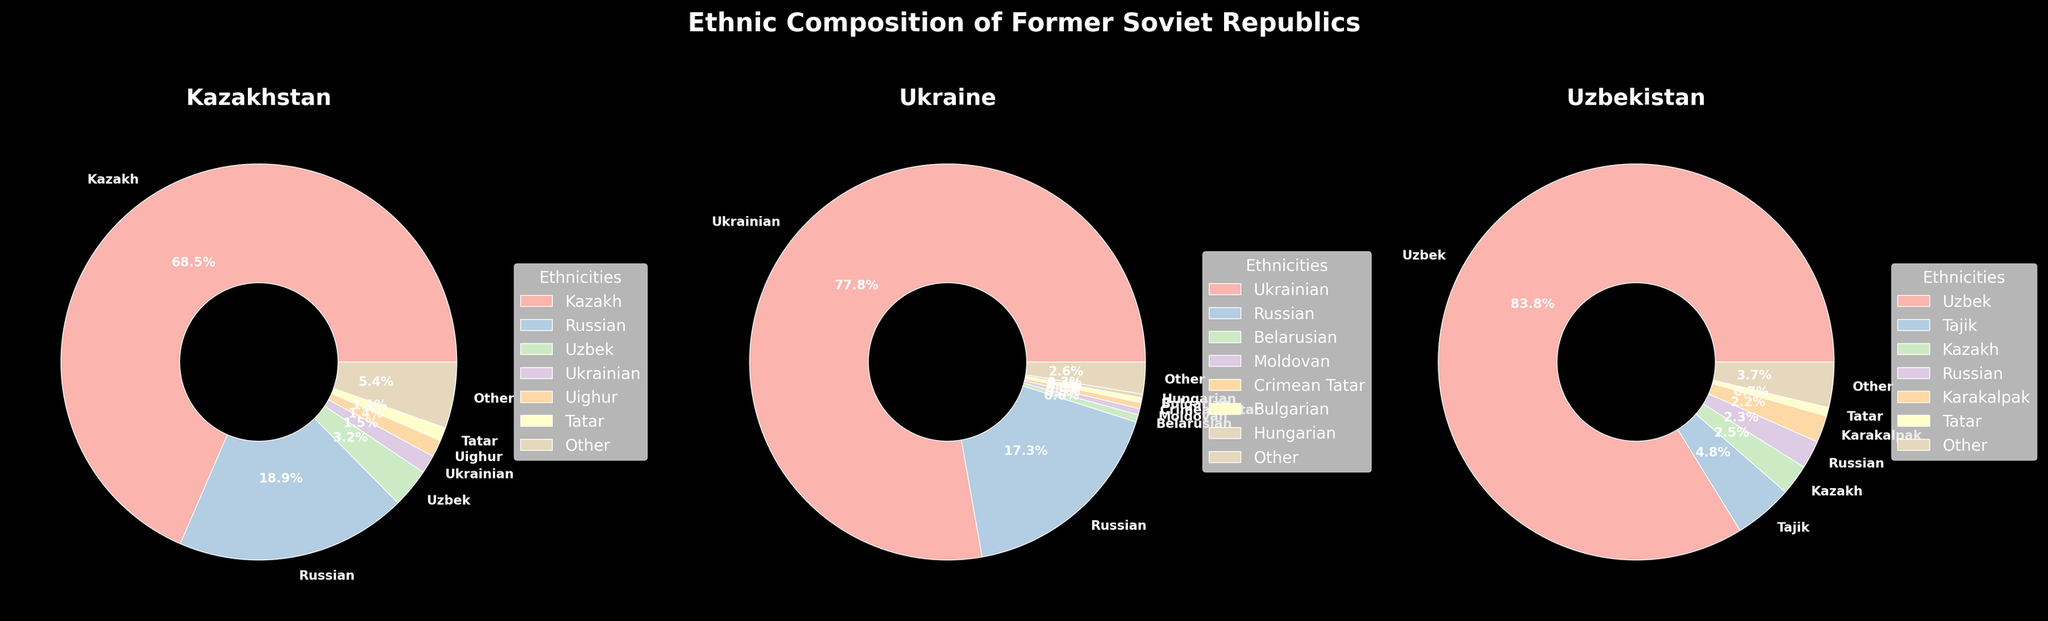what percentage of the population in Kazakhstan is non-Kazakh? To find the percentage of the population in Kazakhstan that is non-Kazakh, add up the percentages of all the other ethnic groups: Russian (18.9%), Uzbek (3.2%), Ukrainian (1.5%), Uighur (1.4%), Tatar (1.1%), and Other (5.4%). Sum these percentages: 18.9 + 3.2 + 1.5 + 1.4 + 1.1 + 5.4 = 31.5%.
Answer: 31.5% Which country has the highest percentage of its population from a single ethnic group? By visually comparing the largest slice of each pie chart, Uzbekistan has the highest percentage of its population from a single ethnic group, with the Uzbek ethnicity making up 83.8%.
Answer: Uzbekistan What is the combined percentage of Russian populations in Kazakhstan and Ukraine? Add the Russian population percentage in Kazakhstan (18.9%) to the Russian population percentage in Ukraine (17.3%). The combined percentage is 18.9 + 17.3 = 36.2%.
Answer: 36.2% Is there a significant difference in the proportion of the main ethnic group between Kazakhstan and Uzbekistan? Compare the percentages of the main ethnic group in both countries. In Kazakhstan, Kazakhs make up 68.5% of the population, while in Uzbekistan, Uzbeks make up 83.8% of the population. The difference is 83.8 - 68.5 = 15.3%. This shows a significant difference.
Answer: Yes, 15.3% What is the percentage difference between Ukrainians and Russians in Ukraine? Subtract the percentage of Russians (17.3%) from the percentage of Ukrainians (77.8%) to find the difference: 77.8 - 17.3 = 60.5%.
Answer: 60.5% How does the ethnic diversity in Kazakhstan compare to that in Uzbekistan? Kazakhstan has several ethnic groups with significant percentages: Kazakh (68.5%), Russian (18.9%), Uzbek (3.2%), and others. Uzbekistan has fewer groups with high percentages: Uzbek (83.8%) and Tajik (4.8%). This indicates higher ethnic diversity in Kazakhstan.
Answer: Kazakhstan is more diverse What is the second-largest ethnic group in Uzbekistan and what percentage of the population does it represent? The second-largest ethnic group in Uzbekistan is Tajik, which represents 4.8% of the population.
Answer: Tajik, 4.8% What color represents the Kazakh ethnic group in Kazakhstan? From the visual observation of the pie chart, the Kazakh ethnic group is represented by the largest slice in the Kazakhstan pie, which is peach.
Answer: Peach What is the total percentage of minor ethnic groups in Ukraine (groups with less than 1%)? Add the percentages of Belarusian (0.6%), Moldovan (0.5%), Crimean Tatar (0.5%), Bulgarian (0.4%), and Hungarian (0.3%). The total percentage is 0.6 + 0.5 + 0.5 + 0.4 + 0.3 = 2.3%.
Answer: 2.3% 